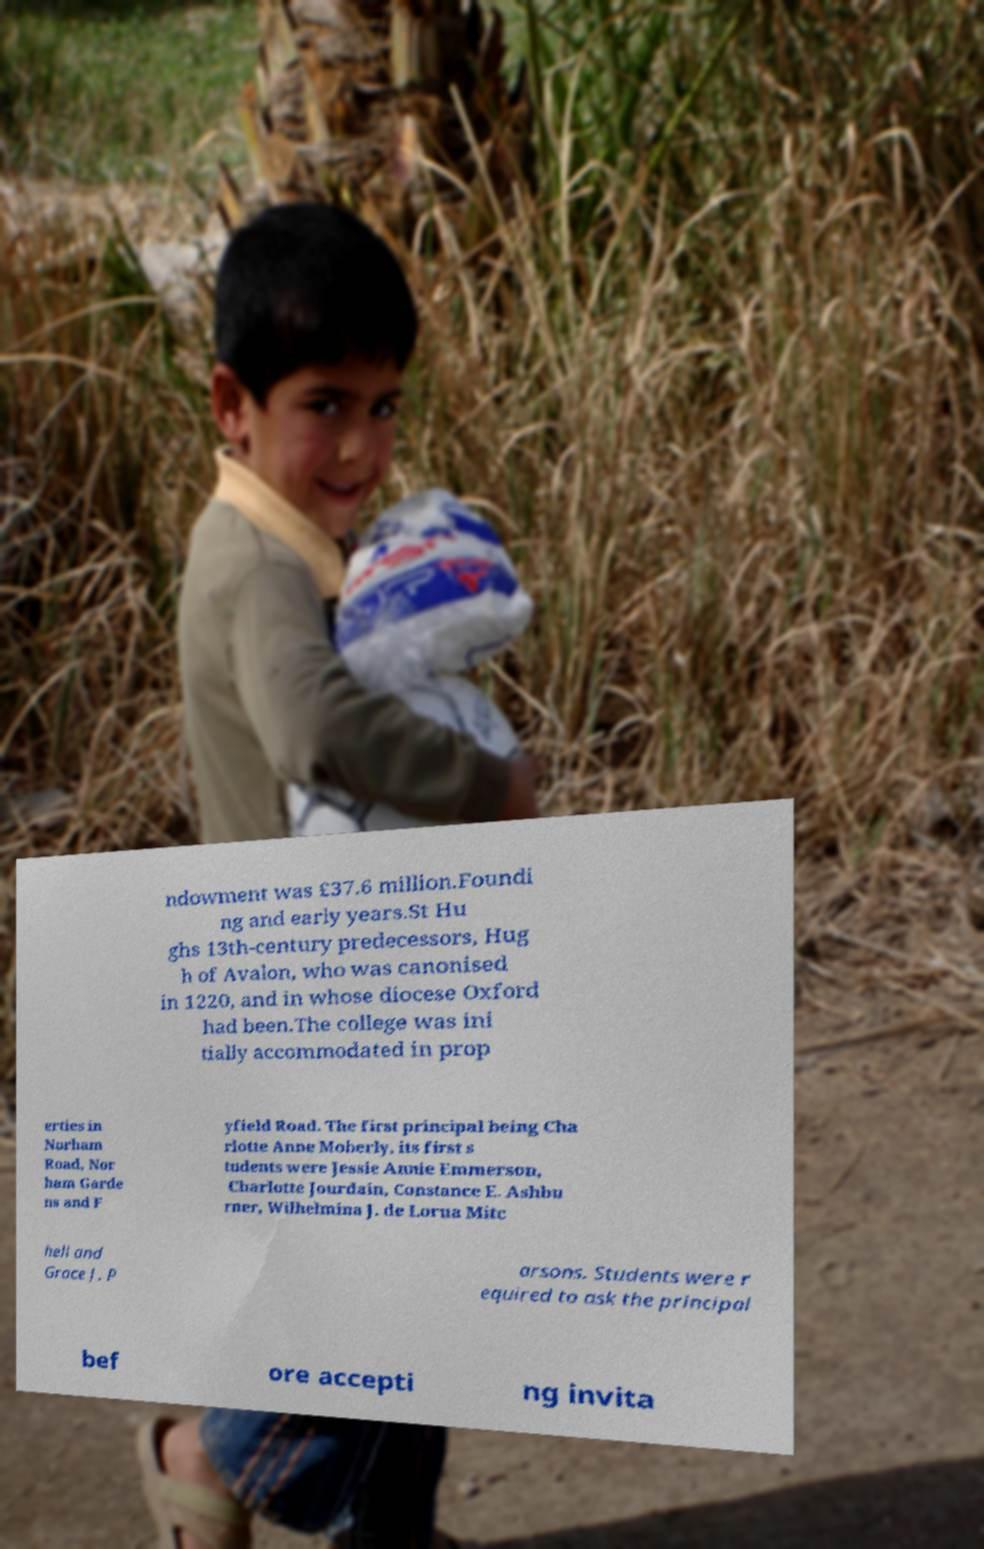Can you read and provide the text displayed in the image?This photo seems to have some interesting text. Can you extract and type it out for me? ndowment was £37.6 million.Foundi ng and early years.St Hu ghs 13th-century predecessors, Hug h of Avalon, who was canonised in 1220, and in whose diocese Oxford had been.The college was ini tially accommodated in prop erties in Norham Road, Nor ham Garde ns and F yfield Road. The first principal being Cha rlotte Anne Moberly, its first s tudents were Jessie Annie Emmerson, Charlotte Jourdain, Constance E. Ashbu rner, Wilhelmina J. de Lorna Mitc hell and Grace J. P arsons. Students were r equired to ask the principal bef ore accepti ng invita 